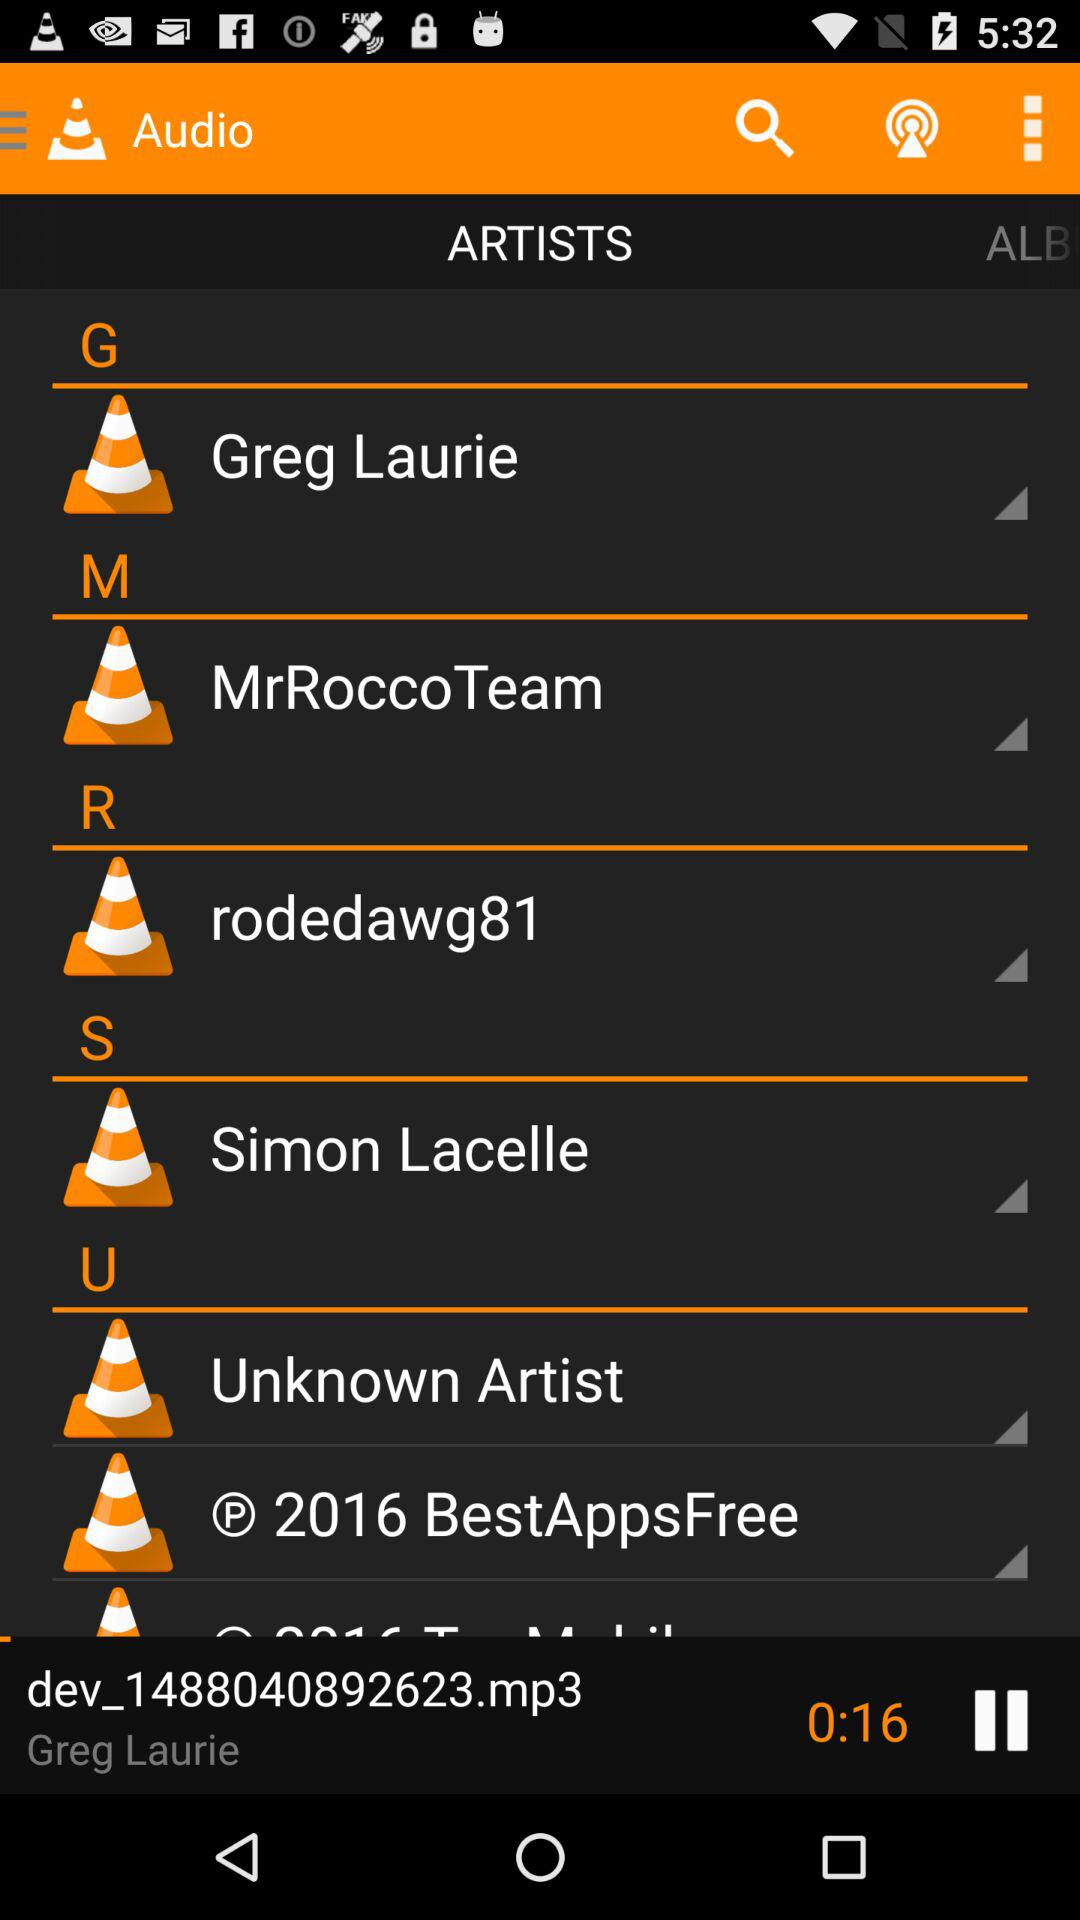How many seconds has the song been playing for?
Answer the question using a single word or phrase. 16 